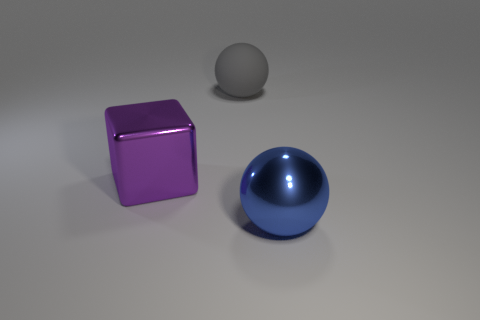Are there an equal number of blue things in front of the large purple metal object and large purple metal things to the left of the big shiny sphere? Indeed, there is an equal number of blue items and large purple metal things as per your description. In front of the large purple cube, we find one blue ball, and to the left of the large, reflective sphere, there is one large purple cube. There's symmetry in the arrangement you've highlighted—each distinct item you mentioned has a counterpart in the scene. 